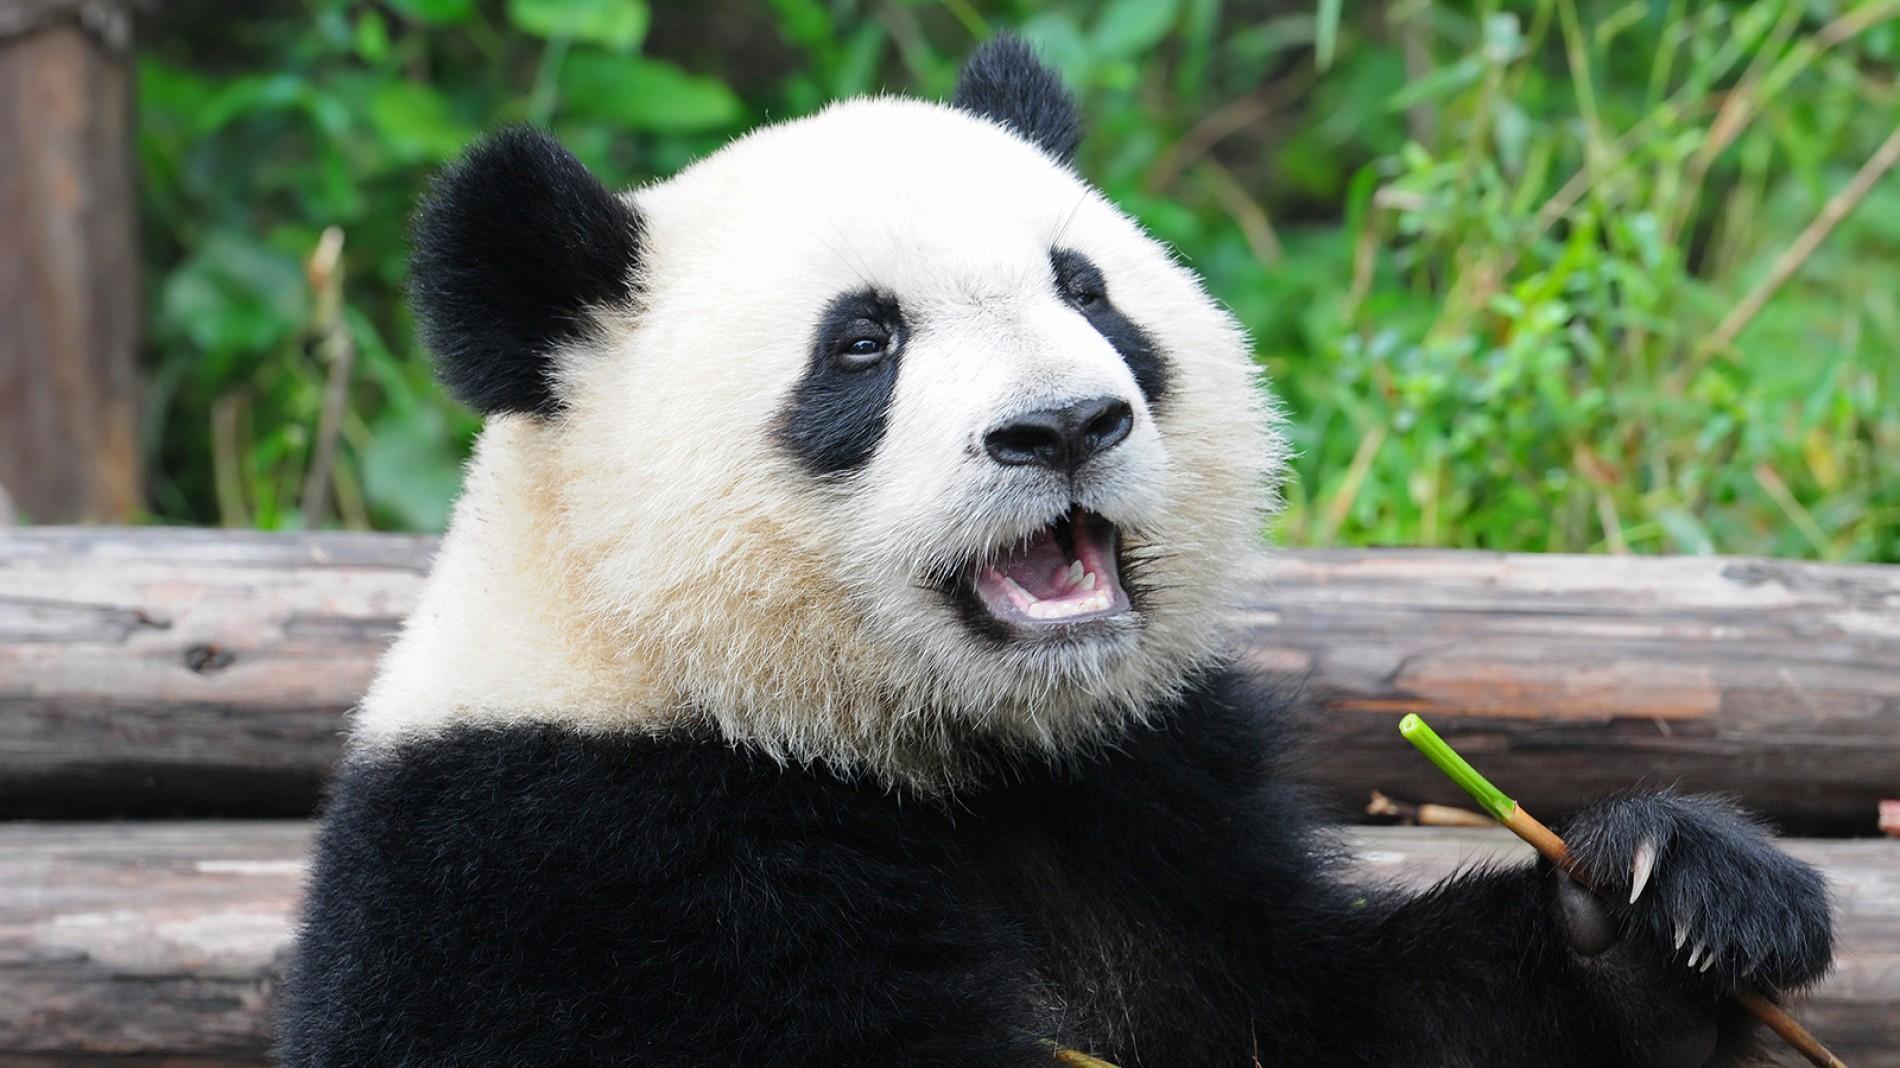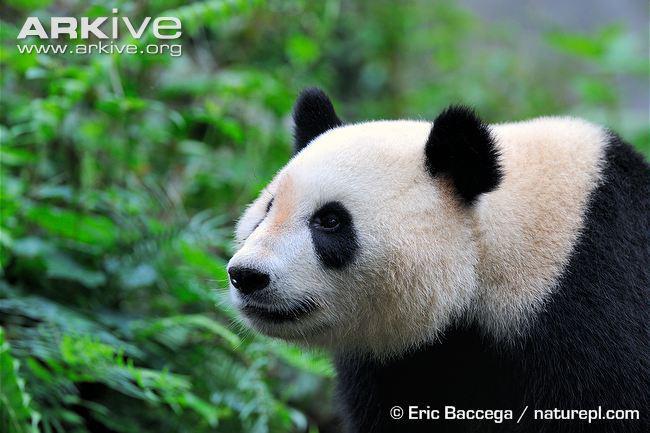The first image is the image on the left, the second image is the image on the right. Considering the images on both sides, is "The panda on the left is nibbling a green stick without leaves on it." valid? Answer yes or no. Yes. The first image is the image on the left, the second image is the image on the right. Analyze the images presented: Is the assertion "There are two pandas in one of the pictures." valid? Answer yes or no. No. 